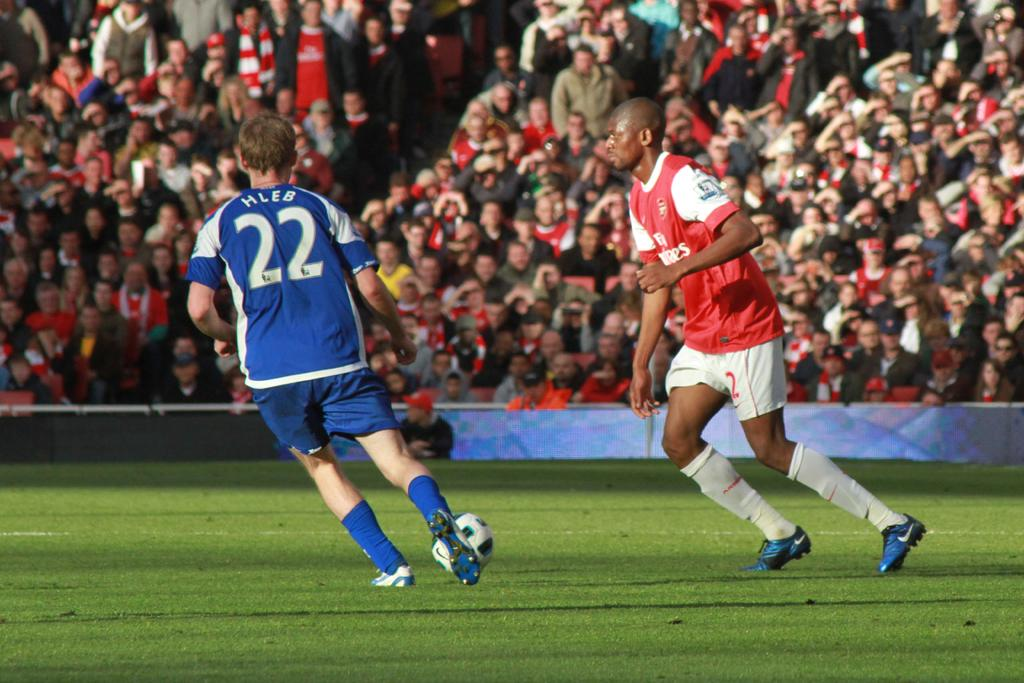<image>
Provide a brief description of the given image. A soccer player number 22 is getting ready to kick the ball 